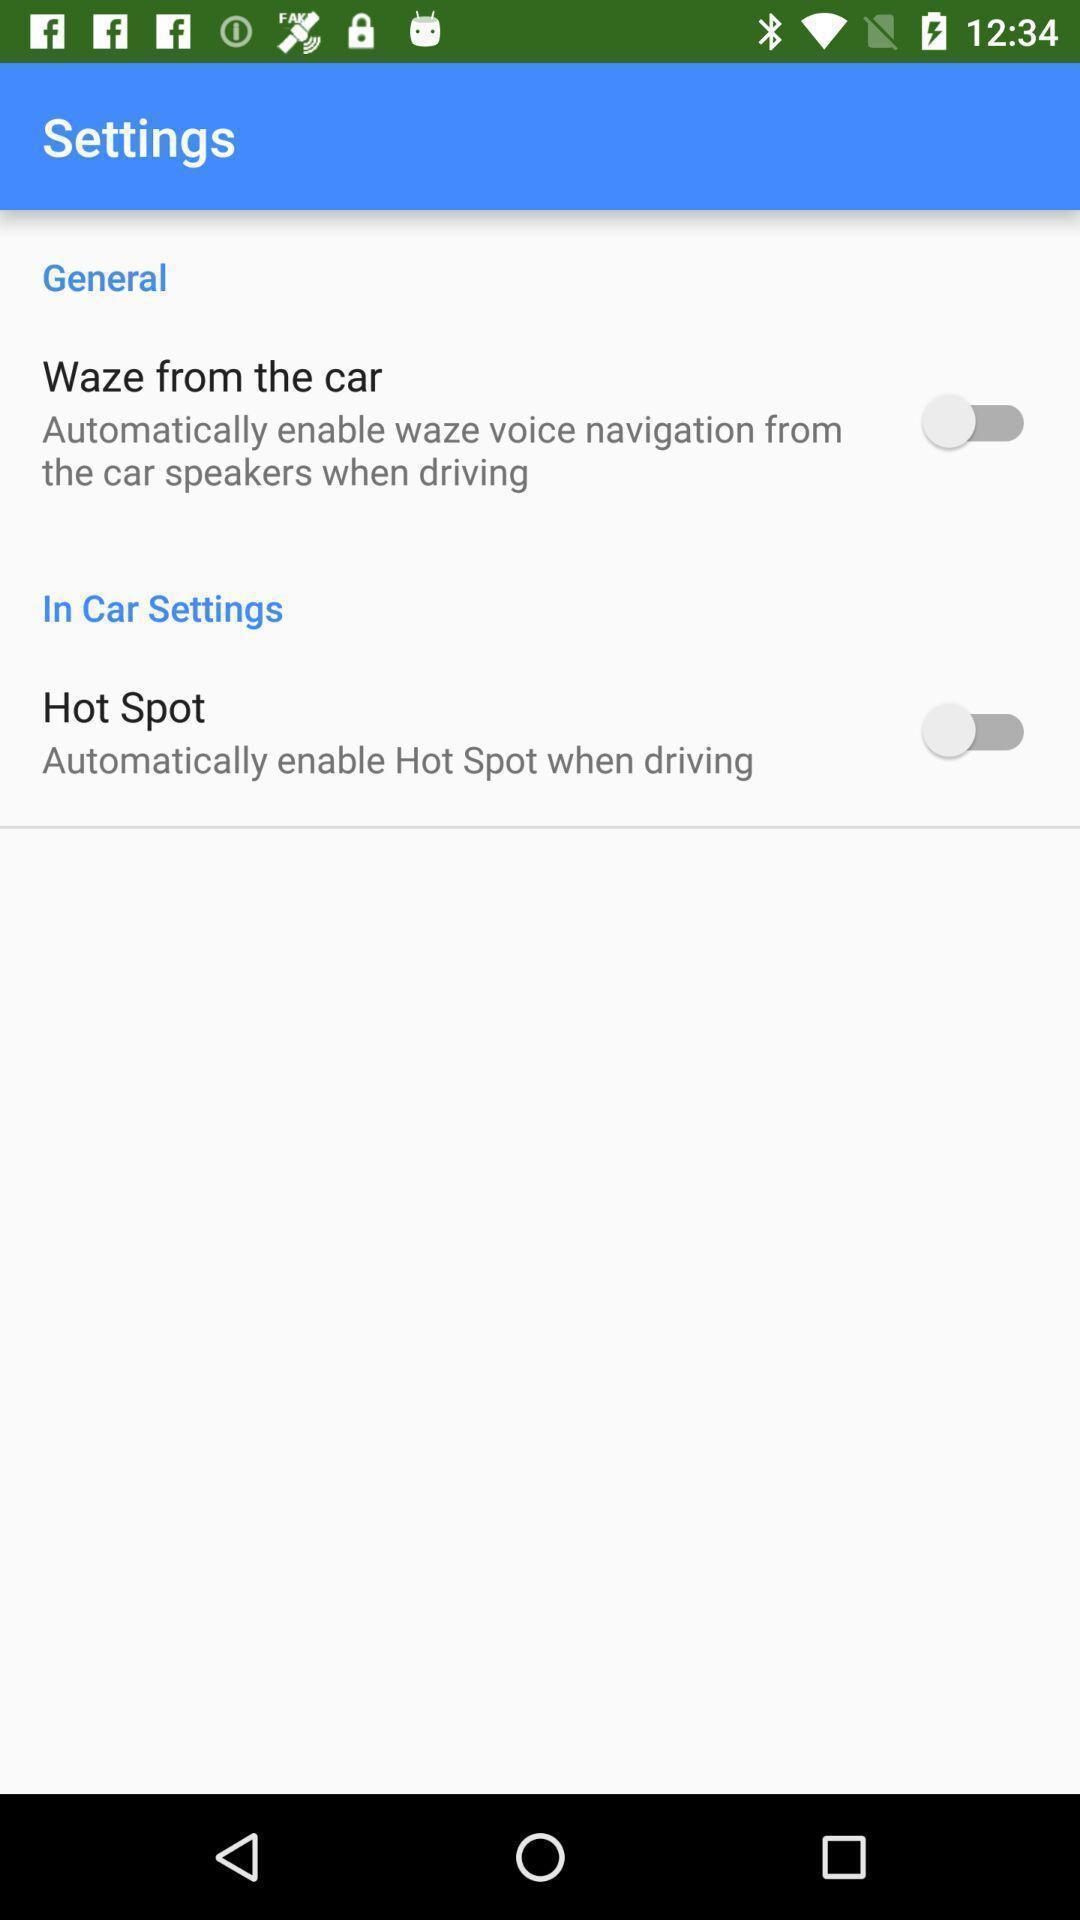What can you discern from this picture? Settings page with few options. 